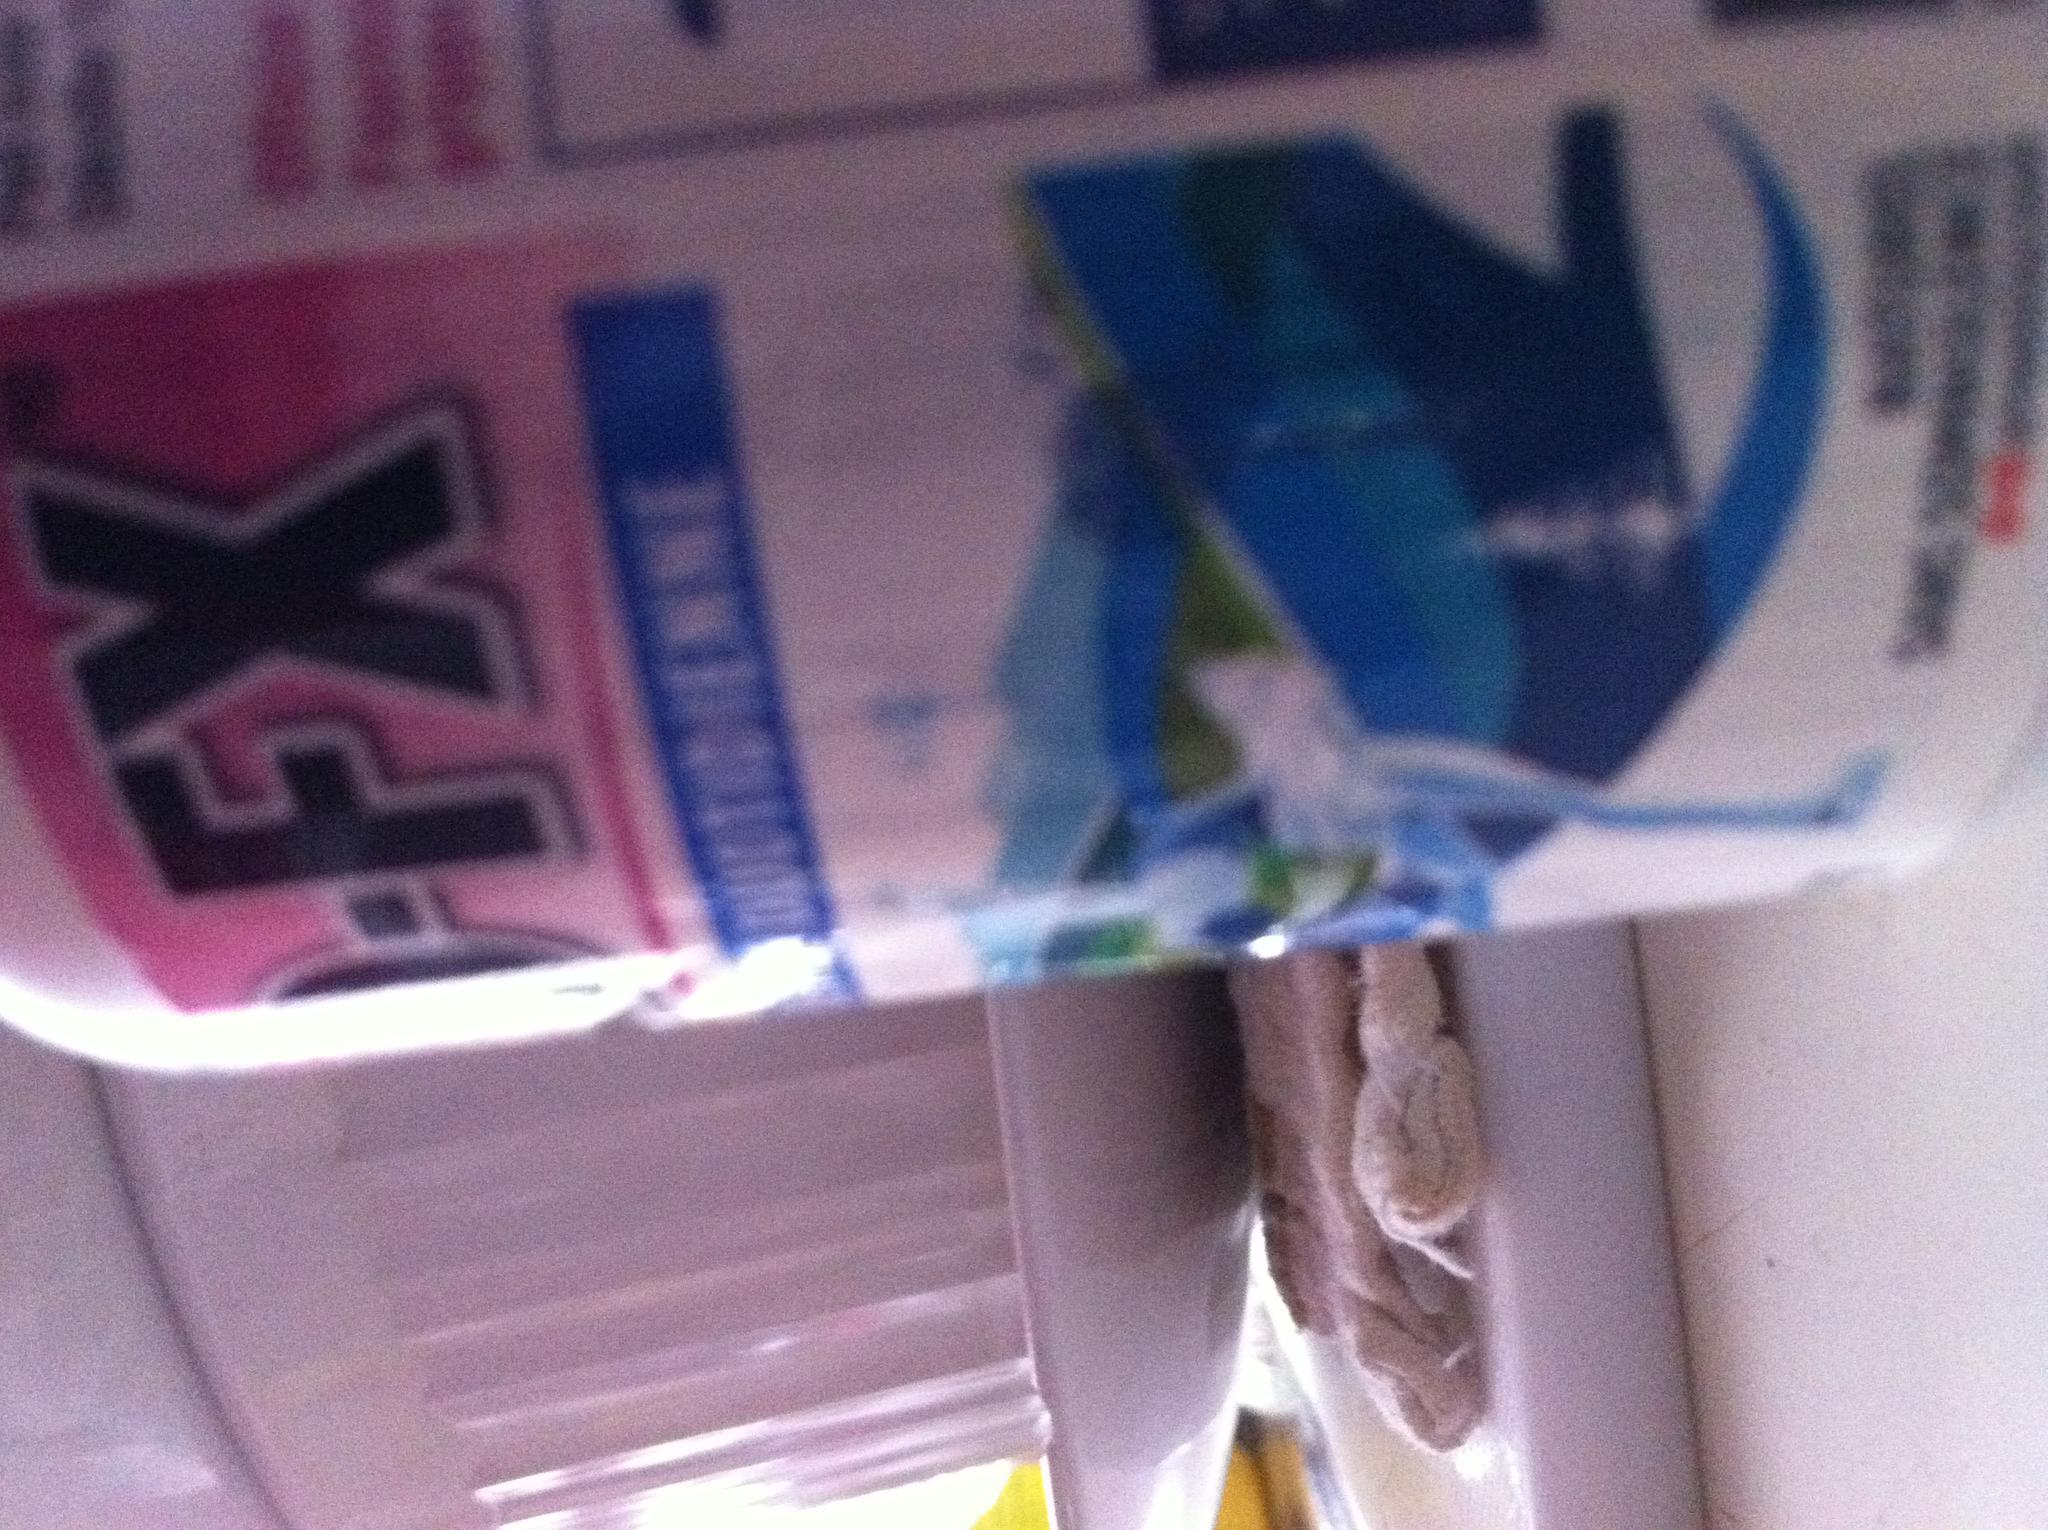Can you provide more details about common types of medications that come in similar packaging? Certainly! Medications that typically use similar packaging include those for cold and flu, allergy relief, and some over-the-counter pain relievers. These packages often feature vibrant graphics and distinct colors to be easily identifiable and to indicate the type of relief they provide. It's important to read the labels for active ingredients and dosage instructions. 